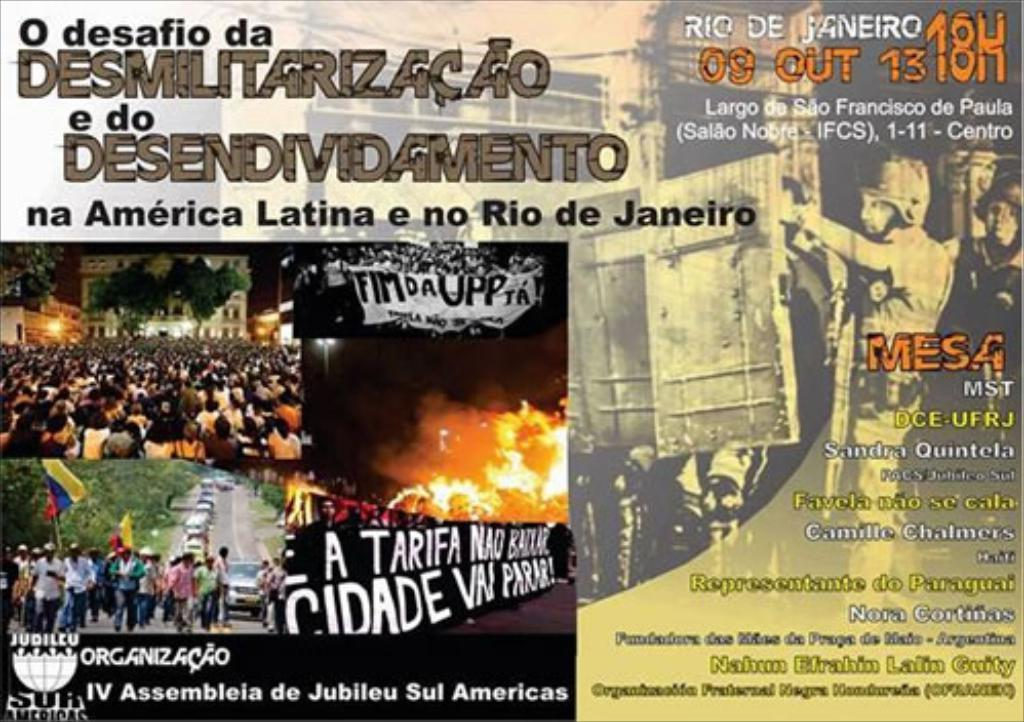<image>
Give a short and clear explanation of the subsequent image. A poster with Portuguese writing on it has pictures of protesters on it. 